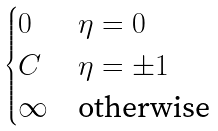Convert formula to latex. <formula><loc_0><loc_0><loc_500><loc_500>\begin{cases} 0 & \eta = 0 \\ C & \eta = \pm 1 \\ \infty & \text {otherwise} \\ \end{cases}</formula> 